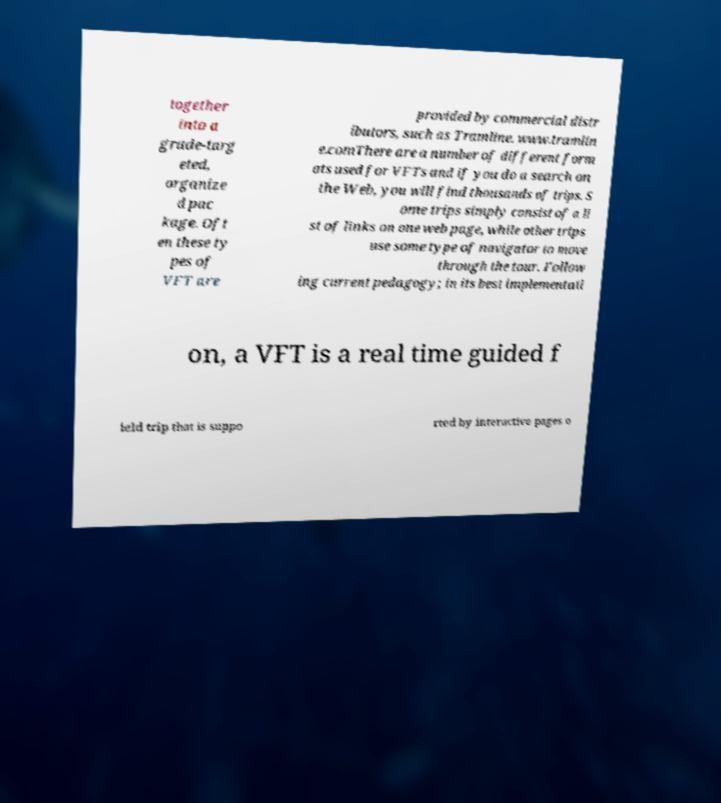Please identify and transcribe the text found in this image. together into a grade-targ eted, organize d pac kage. Oft en these ty pes of VFT are provided by commercial distr ibutors, such as Tramline. www.tramlin e.comThere are a number of different form ats used for VFTs and if you do a search on the Web, you will find thousands of trips. S ome trips simply consist of a li st of links on one web page, while other trips use some type of navigator to move through the tour. Follow ing current pedagogy; in its best implementati on, a VFT is a real time guided f ield trip that is suppo rted by interactive pages o 